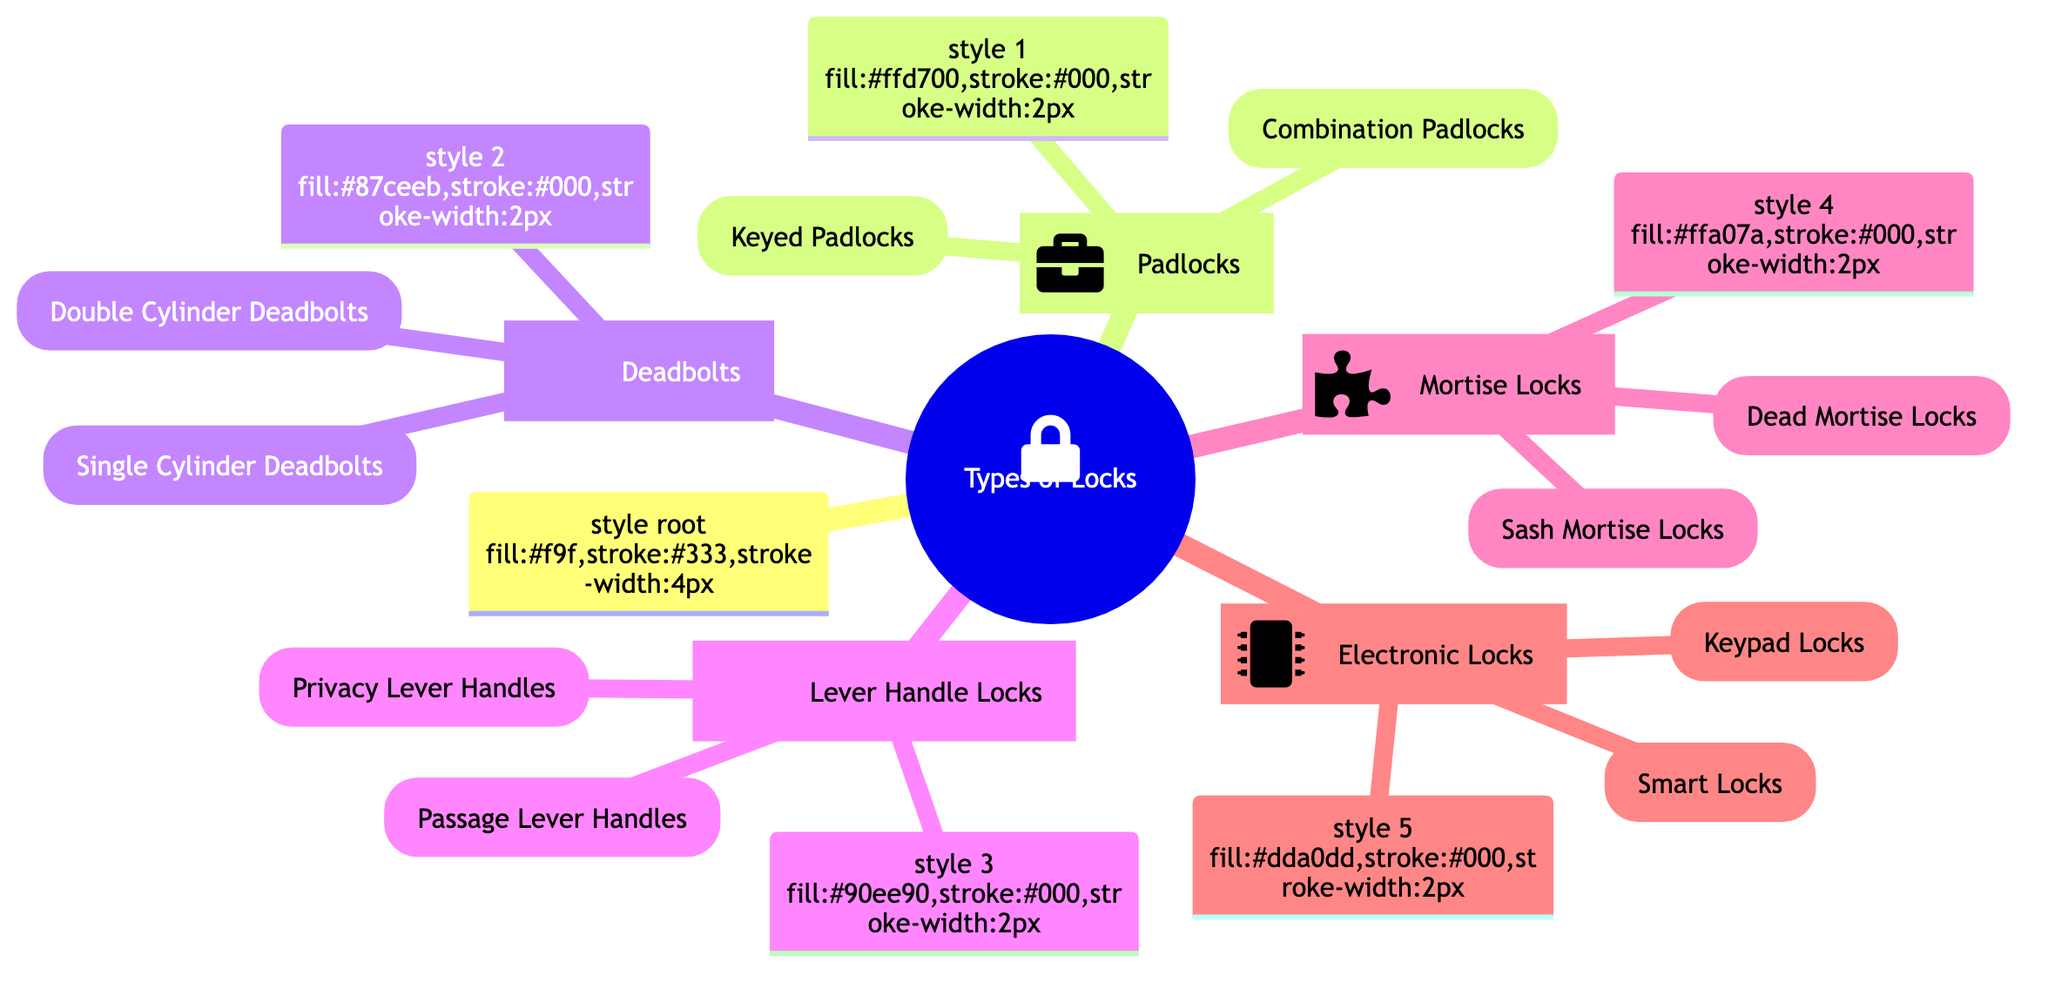What types of locks are included in the diagram? The diagram lists five types of locks: Padlocks, Deadbolts, Lever Handle Locks, Mortise Locks, and Electronic Locks.
Answer: Padlocks, Deadbolts, Lever Handle Locks, Mortise Locks, Electronic Locks How many mechanisms are associated with Lever Handle Locks? Lever Handle Locks have two mechanisms listed: Privacy Lever Handles and Passage Lever Handles. So, the total is two.
Answer: 2 Which lock requires a key to unlock from both inside and outside? The diagram indicates that Double Cylinder Deadbolts are the type that requires a key for access from both sides.
Answer: Double Cylinder Deadbolts What is unique about Electronic Locks compared to other locks? Electronic Locks utilize electronic components rather than traditional mechanical parts, making them distinct from the other types of locks listed.
Answer: Electronic components How many types of Padlocks are mentioned in the diagram? The diagram specifies two types of Padlocks: Combination Padlocks and Keyed Padlocks, thus there are two types.
Answer: 2 Which type of lock is described as portable? According to the diagram, Padlocks are described as portable locks with a shackle that can be passed through an opening.
Answer: Padlocks What type of Mortise Lock features both a deadbolt and a latch? The Sash Mortise Locks are the ones that feature both a deadbolt and a latch operated by a handle according to the information in the diagram.
Answer: Sash Mortise Locks What is the mechanism of Keypad Locks? Keypad Locks require entering a numerical code for access, which is stated in the description for this type of lock in the diagram.
Answer: Numerical code What is the function of Privacy Lever Handles? Privacy Lever Handles lock using a push button or turn piece, typically used for bedrooms and bathrooms as detailed in the diagram.
Answer: Push button or turn piece 